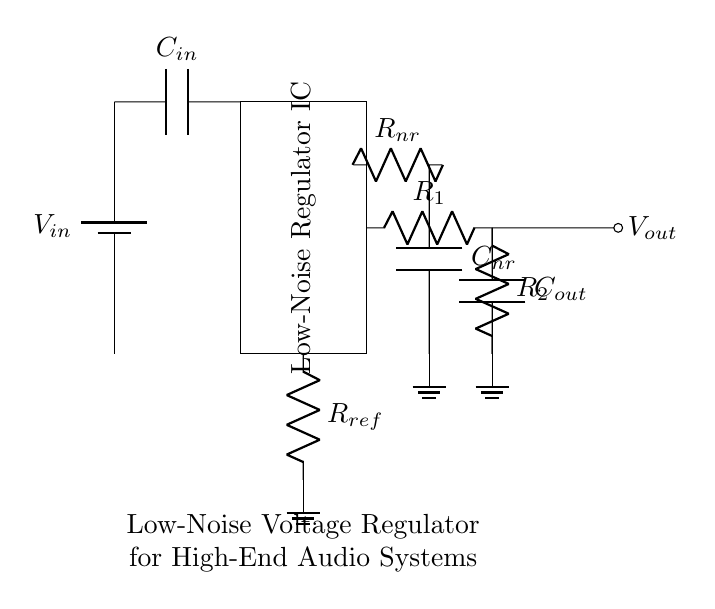What is the input component of this circuit? The input component is a battery, indicated in the diagram as the source of input voltage, labeled as V_in.
Answer: battery What does C_in represent in the circuit? C_in represents the input capacitor, which helps smooth the input voltage before it reaches the voltage regulator. It is connected directly after the battery symbol in the diagram.
Answer: input capacitor Which component is responsible for noise reduction? The components responsible for noise reduction are labeled R_nr (resistor) and C_nr (capacitor), which form a low-pass filter configuration to minimize noise.
Answer: R_nr and C_nr What is the overall purpose of this circuit? The overall purpose of this circuit is to regulate voltage with low noise, which is essential for high-end audio systems to prevent audio distortion. The purpose is explicitly stated under the component labels.
Answer: low-noise voltage regulation What kind of feedback mechanism is used in this circuit? The feedback mechanism in this circuit is implemented using resistors R_1 and R_2, where they create a voltage divider that feeds back to the voltage regulator IC for maintaining the output voltage.
Answer: voltage divider How many output capacitors are present in this circuit? There is one output capacitor (C_out) present in the circuit to help stabilize the output voltage further and filter any remaining noise.
Answer: one What label indicates the output voltage in this circuit? The output voltage is indicated by the label V_out, which is shown at the end of the output line connected to C_out.
Answer: V_out 